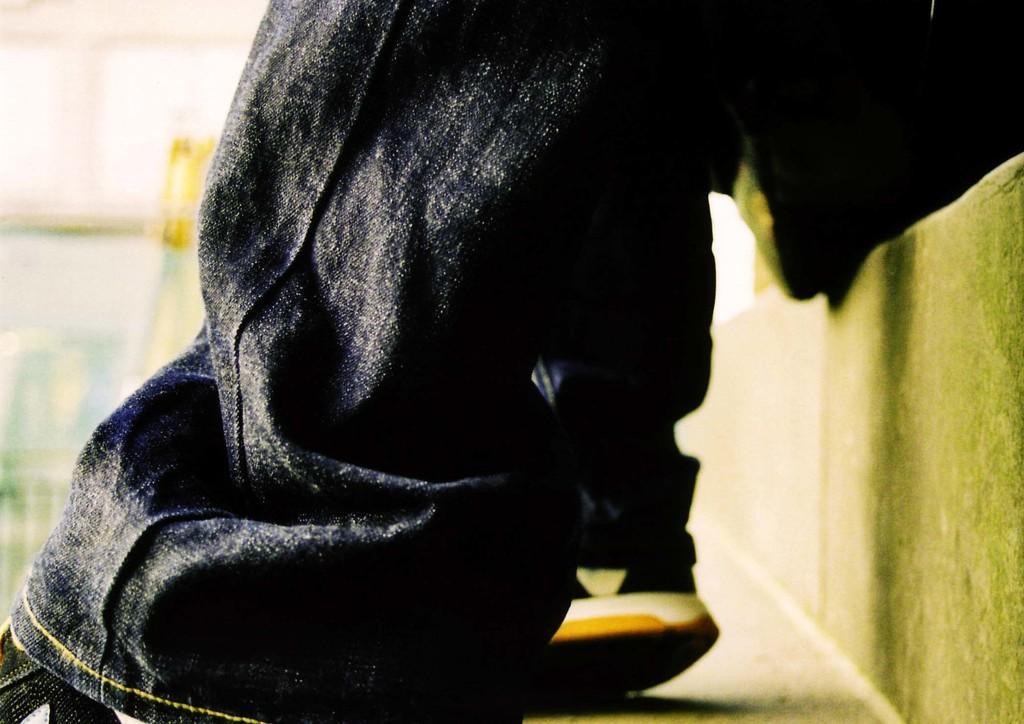Can you describe this image briefly? In this image I can see the person's legs with dress and footwear. And there is a blurred background. 